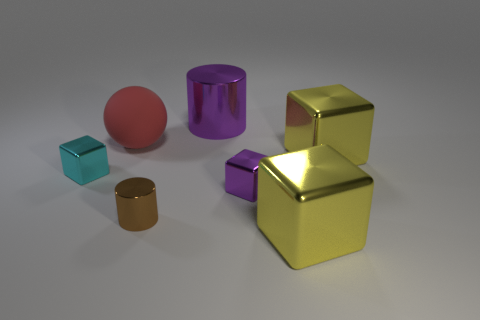Is there anything else that is made of the same material as the sphere?
Your answer should be very brief. No. What number of rubber things are green cubes or brown objects?
Your answer should be very brief. 0. What shape is the object that is the same color as the big cylinder?
Offer a terse response. Cube. What number of large yellow metal cubes are there?
Give a very brief answer. 2. Do the large thing behind the large red matte sphere and the tiny cube that is in front of the small cyan cube have the same material?
Ensure brevity in your answer.  Yes. The brown thing that is made of the same material as the cyan object is what size?
Your answer should be compact. Small. There is a big object that is behind the large ball; what shape is it?
Your answer should be compact. Cylinder. There is a tiny thing that is on the left side of the big rubber object; is its color the same as the metal cylinder behind the large matte object?
Ensure brevity in your answer.  No. What size is the object that is the same color as the large cylinder?
Offer a terse response. Small. Are any small green rubber cylinders visible?
Ensure brevity in your answer.  No. 